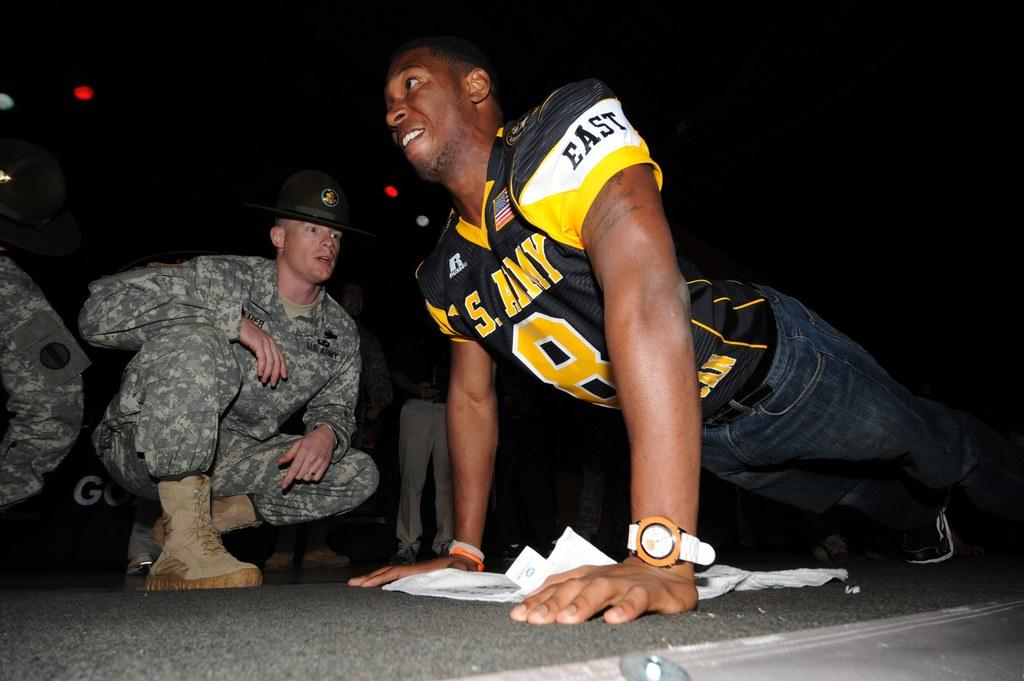<image>
Write a terse but informative summary of the picture. A guy is wearing a jersey with east on the arm. 